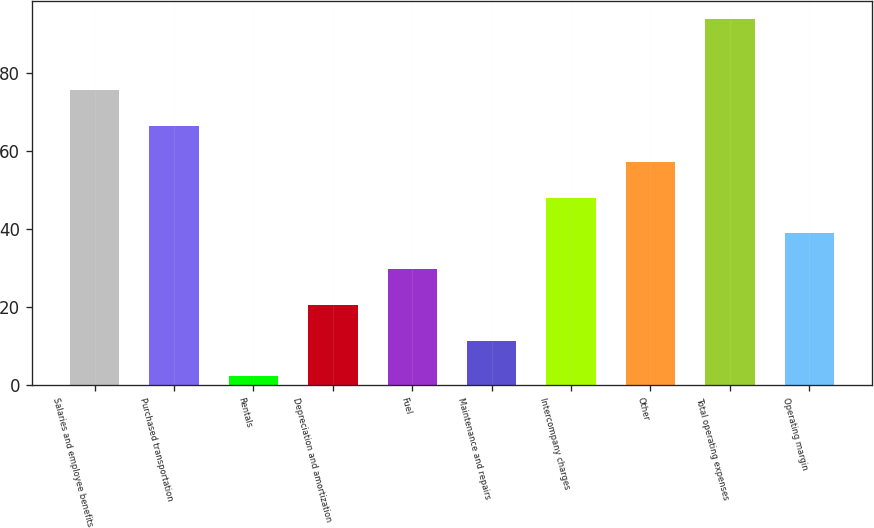Convert chart to OTSL. <chart><loc_0><loc_0><loc_500><loc_500><bar_chart><fcel>Salaries and employee benefits<fcel>Purchased transportation<fcel>Rentals<fcel>Depreciation and amortization<fcel>Fuel<fcel>Maintenance and repairs<fcel>Intercompany charges<fcel>Other<fcel>Total operating expenses<fcel>Operating margin<nl><fcel>75.46<fcel>66.29<fcel>2.1<fcel>20.44<fcel>29.61<fcel>11.27<fcel>47.95<fcel>57.12<fcel>93.8<fcel>38.78<nl></chart> 